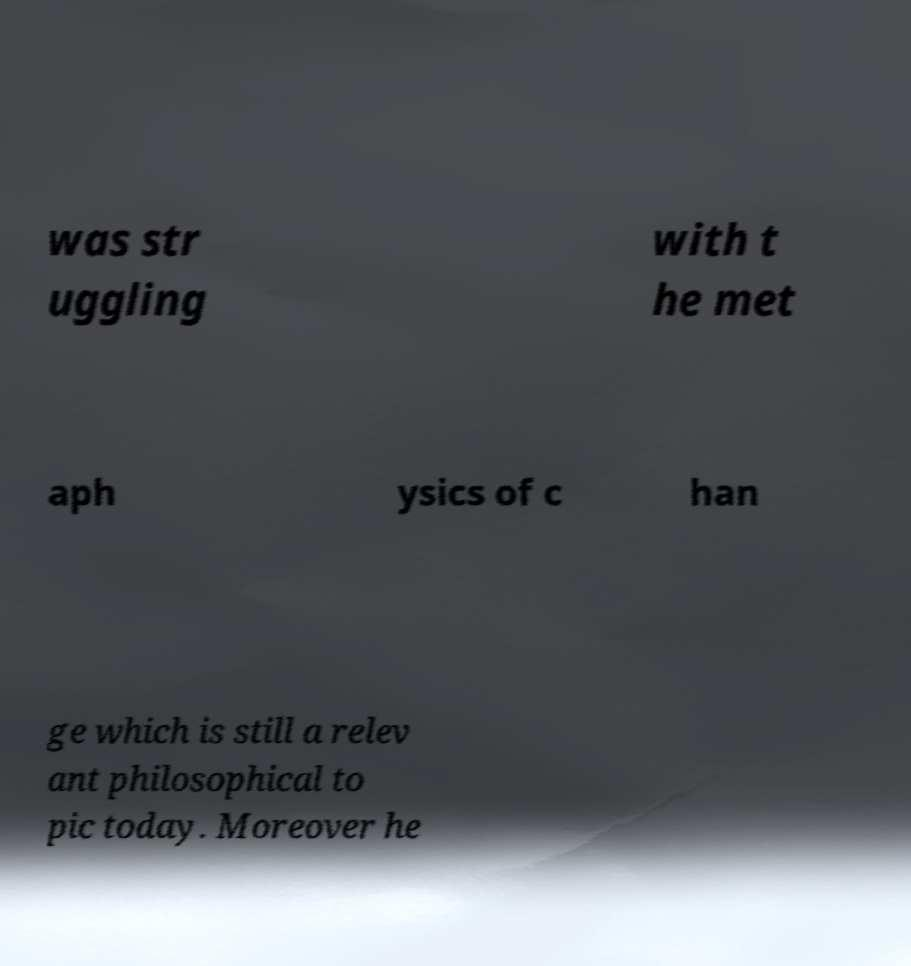Please identify and transcribe the text found in this image. was str uggling with t he met aph ysics of c han ge which is still a relev ant philosophical to pic today. Moreover he 